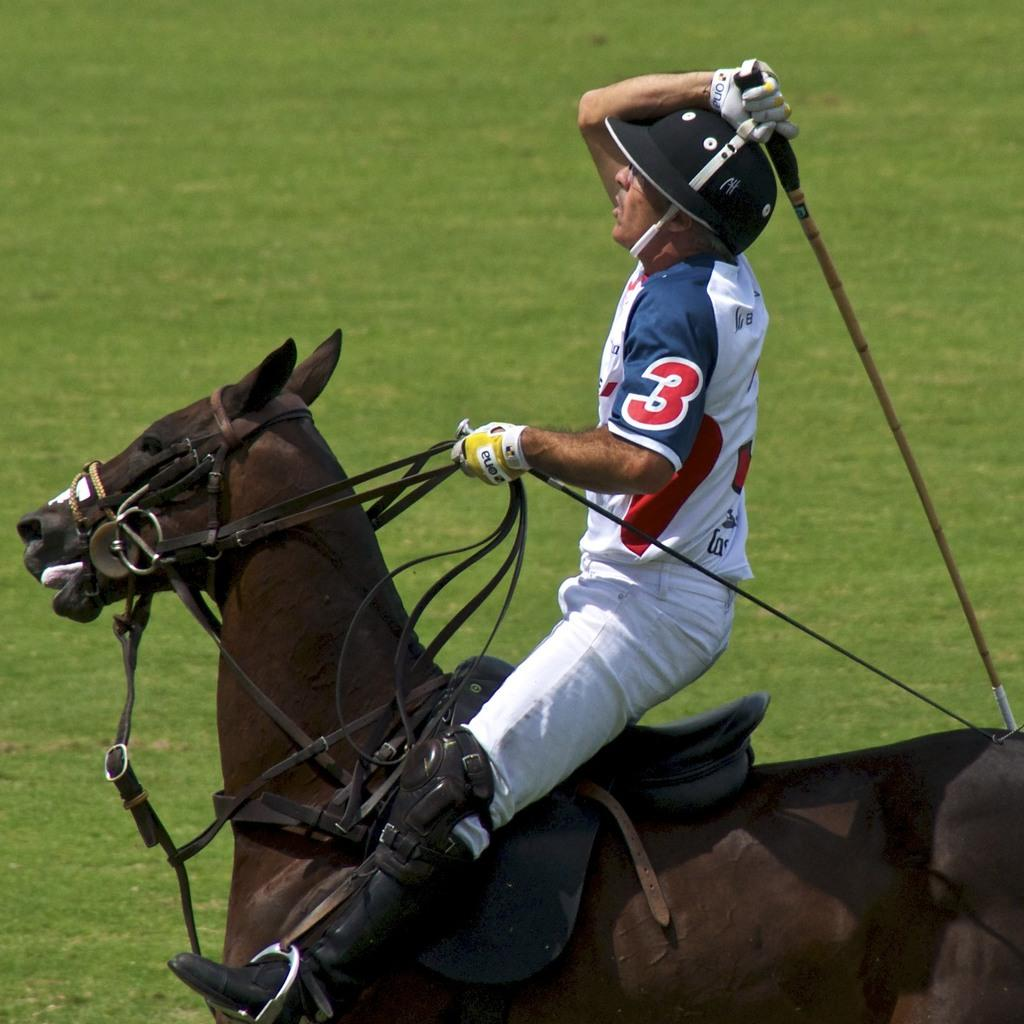Who or what is the main subject in the image? There is a person in the image. What is the person doing in the image? The person is sitting on a horse. What is the person holding in the image? The person is holding a stick. What type of environment is visible in the image? There is grass visible in the image. How many giants can be seen in the image? There are no giants present in the image. What is the cause of death for the person in the image? There is no indication of death in the image; the person is sitting on a horse. 